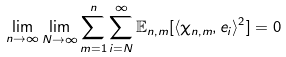Convert formula to latex. <formula><loc_0><loc_0><loc_500><loc_500>\lim _ { n \to \infty } \lim _ { N \to \infty } \sum _ { m = 1 } ^ { n } \sum _ { i = N } ^ { \infty } \mathbb { E } _ { n , m } [ \langle \chi _ { n , m } , e _ { i } \rangle ^ { 2 } ] = 0</formula> 